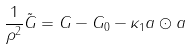<formula> <loc_0><loc_0><loc_500><loc_500>\frac { 1 } { \rho ^ { 2 } } \tilde { G } & = G - G _ { 0 } - \kappa _ { 1 } a \odot a</formula> 